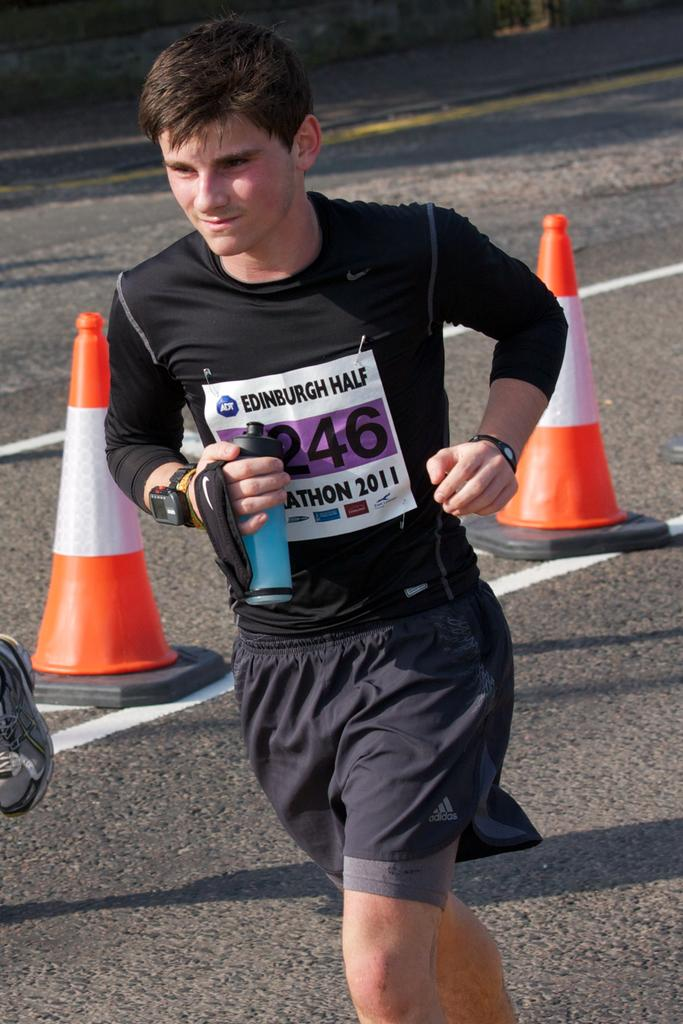What is the person in the image doing? The person is running in the image. Where is the person running? The person is on the road. What can be seen in the image besides the person running? There is an orange and white color object in the image. What is visible in the background of the image? There appears to be a wall in the background of the image. What direction is the news being broadcasted from in the image? There is no news broadcast present in the image. Does the orange and white color object have a tail in the image? The orange and white color object in the image does not have a tail, as it is not an animal or a creature. 